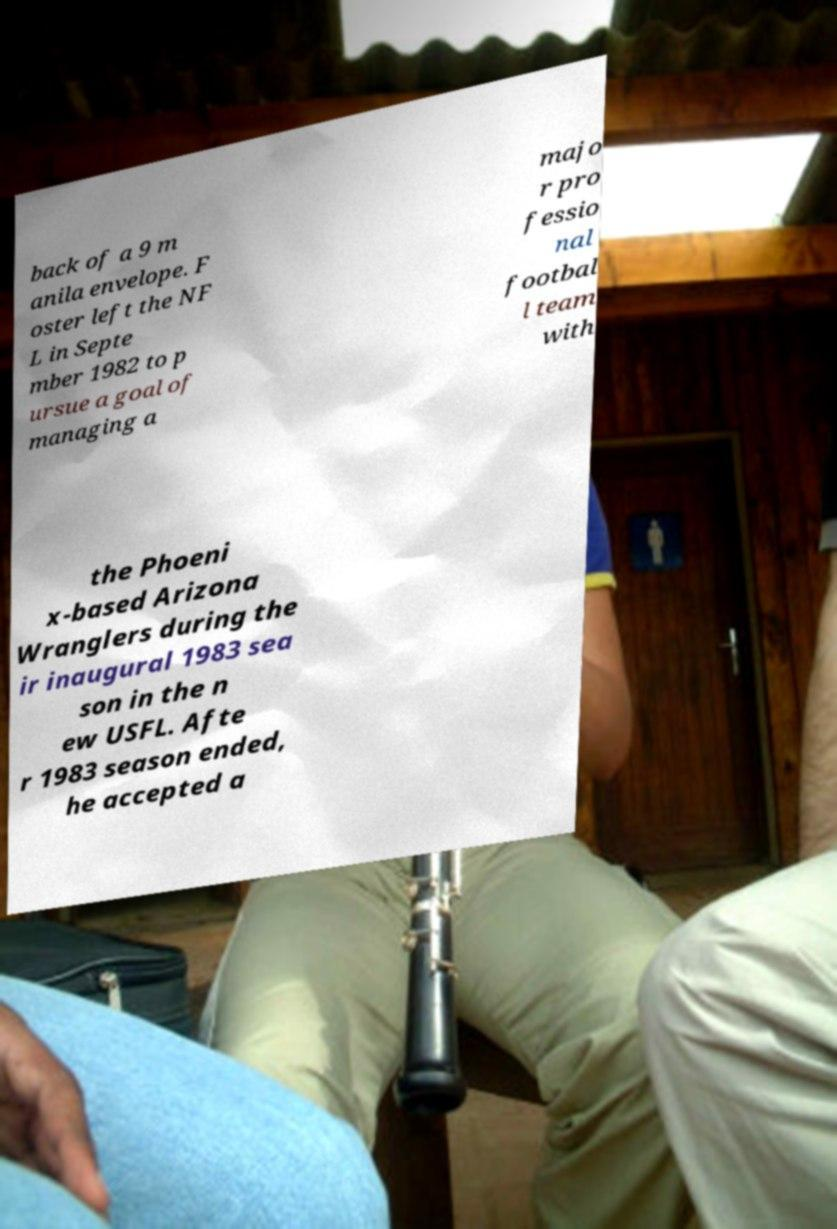There's text embedded in this image that I need extracted. Can you transcribe it verbatim? back of a 9 m anila envelope. F oster left the NF L in Septe mber 1982 to p ursue a goal of managing a majo r pro fessio nal footbal l team with the Phoeni x-based Arizona Wranglers during the ir inaugural 1983 sea son in the n ew USFL. Afte r 1983 season ended, he accepted a 